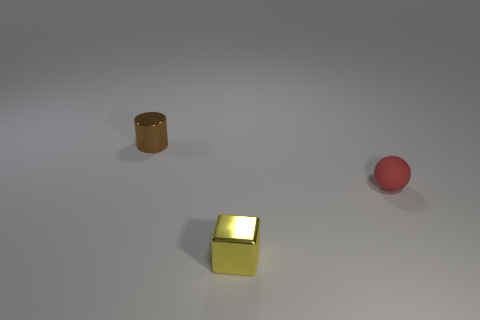Subtract all blocks. How many objects are left? 2 Add 2 rubber things. How many objects exist? 5 Subtract all yellow blocks. Subtract all yellow metal objects. How many objects are left? 1 Add 2 small cylinders. How many small cylinders are left? 3 Add 3 tiny red rubber objects. How many tiny red rubber objects exist? 4 Subtract 0 blue spheres. How many objects are left? 3 Subtract all green cylinders. Subtract all purple cubes. How many cylinders are left? 1 Subtract all blue blocks. How many purple balls are left? 0 